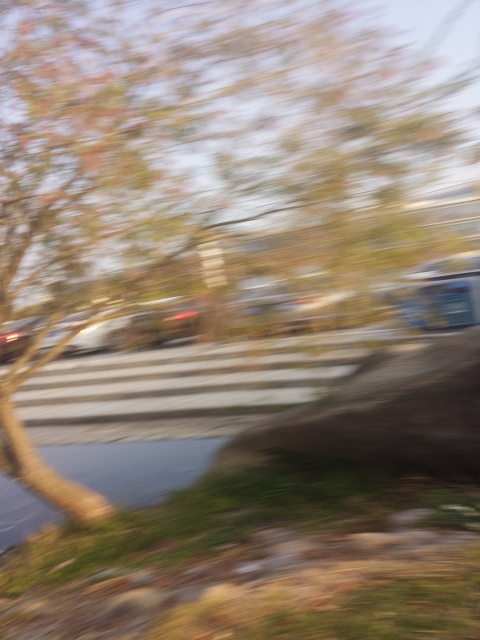What emotions or feelings might the blurred effect in this photo evoke? The motion blur might evoke feelings of haste, confusion, or chaos due to the lack of focus and clarity. For some viewers, it may convey a sense of rushing or the passage of time. It can also create a dreamlike or ethereal atmosphere, depending on the context and the viewer's interpretation. 